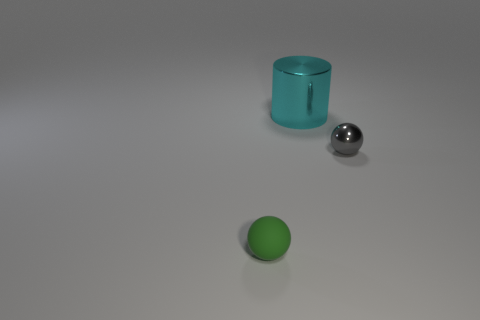Can you guess what the objects are used for? Without additional context, it's difficult to determine the exact use of these objects. The large silver sphere might be a decorative object or part of some larger mechanical structure. The green sphere could be a simple ball used for play, and the cyan cylinder could serve as a container, a vase, or an architectural model due to its shape and transparency. 